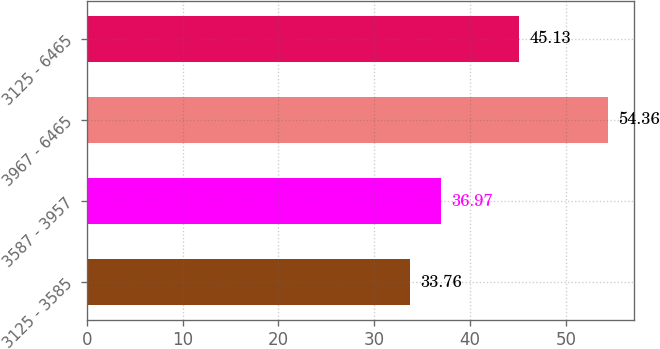Convert chart to OTSL. <chart><loc_0><loc_0><loc_500><loc_500><bar_chart><fcel>3125 - 3585<fcel>3587 - 3957<fcel>3967 - 6465<fcel>3125 - 6465<nl><fcel>33.76<fcel>36.97<fcel>54.36<fcel>45.13<nl></chart> 